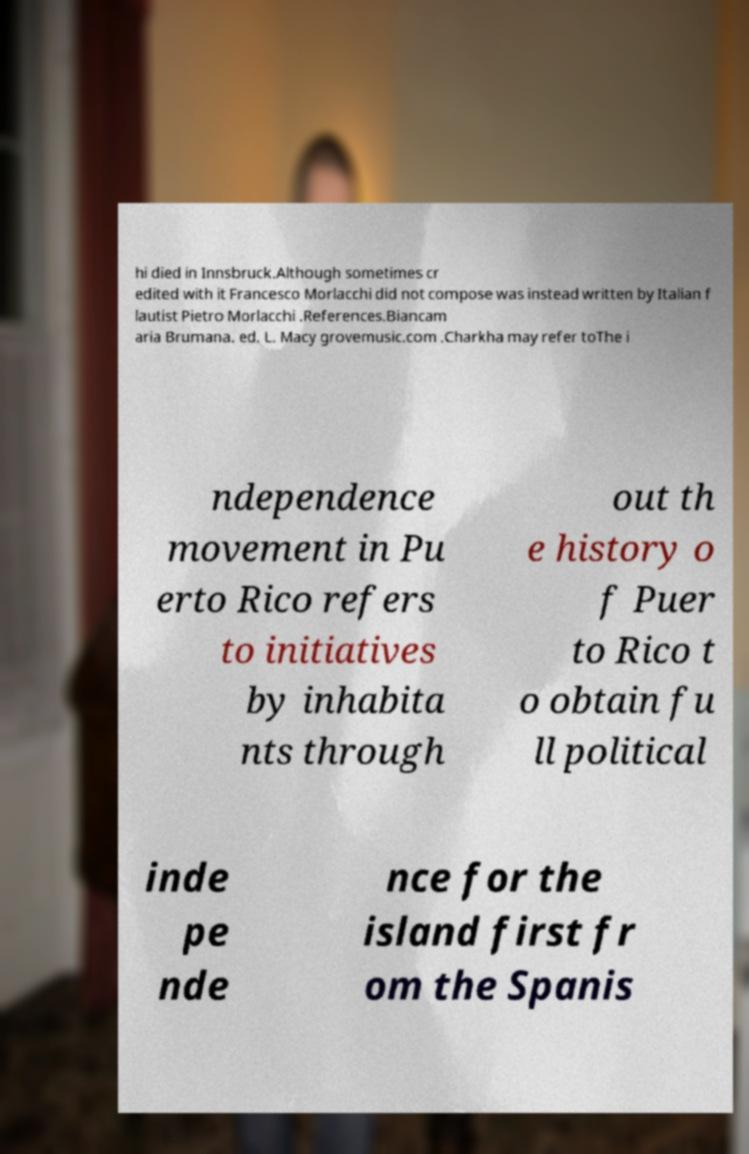There's text embedded in this image that I need extracted. Can you transcribe it verbatim? hi died in Innsbruck.Although sometimes cr edited with it Francesco Morlacchi did not compose was instead written by Italian f lautist Pietro Morlacchi .References.Biancam aria Brumana. ed. L. Macy grovemusic.com .Charkha may refer toThe i ndependence movement in Pu erto Rico refers to initiatives by inhabita nts through out th e history o f Puer to Rico t o obtain fu ll political inde pe nde nce for the island first fr om the Spanis 